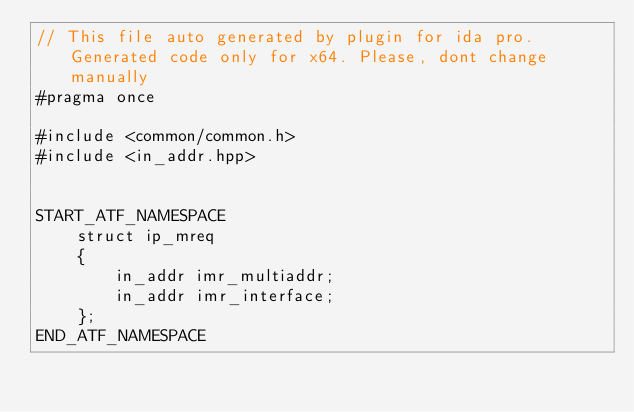<code> <loc_0><loc_0><loc_500><loc_500><_C++_>// This file auto generated by plugin for ida pro. Generated code only for x64. Please, dont change manually
#pragma once

#include <common/common.h>
#include <in_addr.hpp>


START_ATF_NAMESPACE
    struct ip_mreq
    {
        in_addr imr_multiaddr;
        in_addr imr_interface;
    };
END_ATF_NAMESPACE
</code> 